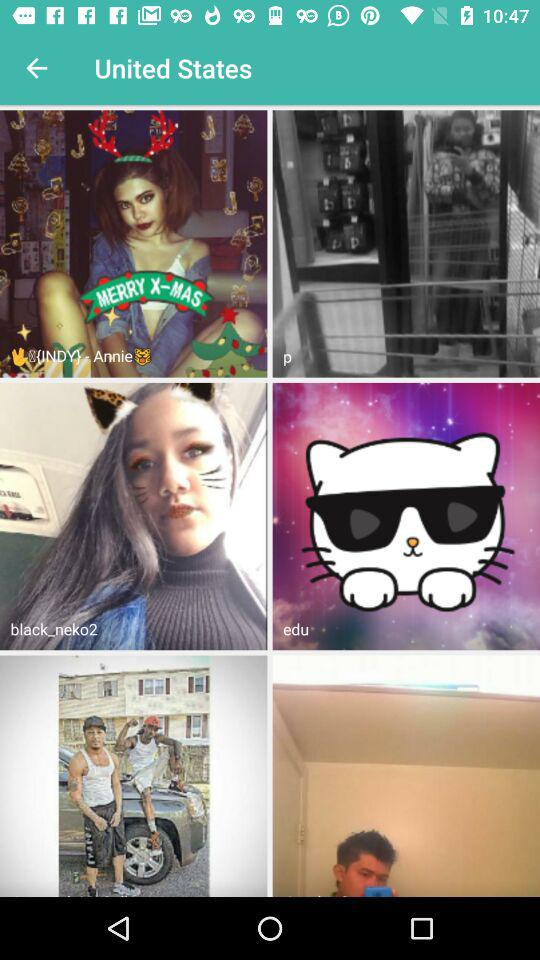What is the country name? The country name is the United States. 